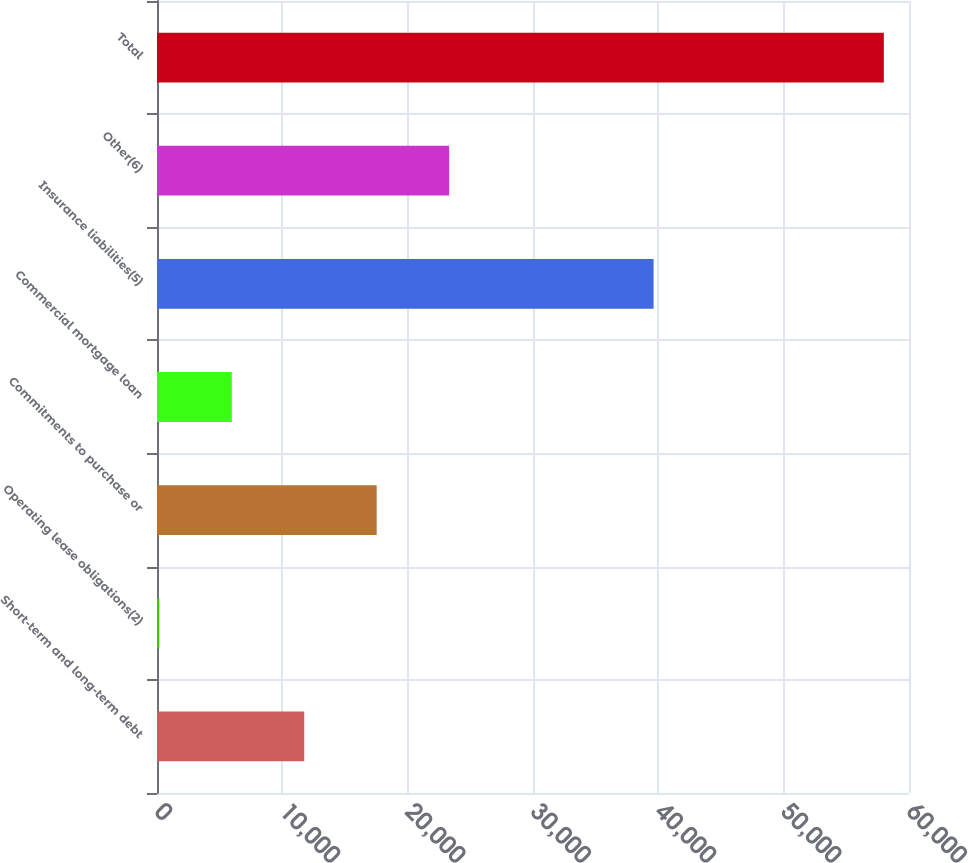Convert chart. <chart><loc_0><loc_0><loc_500><loc_500><bar_chart><fcel>Short-term and long-term debt<fcel>Operating lease obligations(2)<fcel>Commitments to purchase or<fcel>Commercial mortgage loan<fcel>Insurance liabilities(5)<fcel>Other(6)<fcel>Total<nl><fcel>11748<fcel>187<fcel>17528.5<fcel>5967.5<fcel>39620<fcel>23309<fcel>57992<nl></chart> 